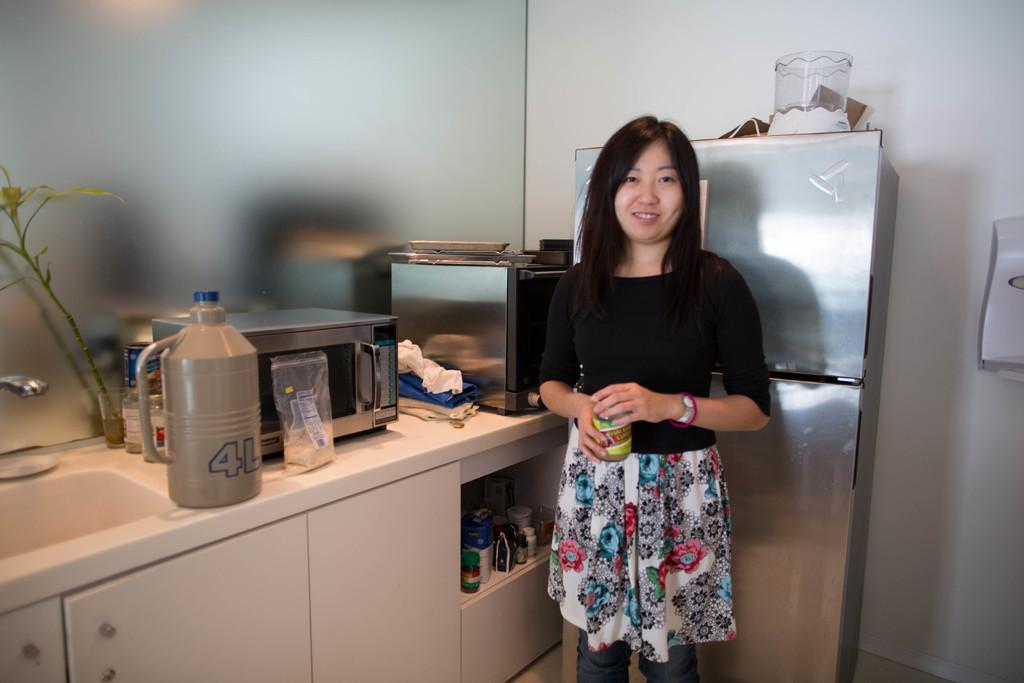<image>
Summarize the visual content of the image. A jug on the kitchen counter says it will hold 4 L. 